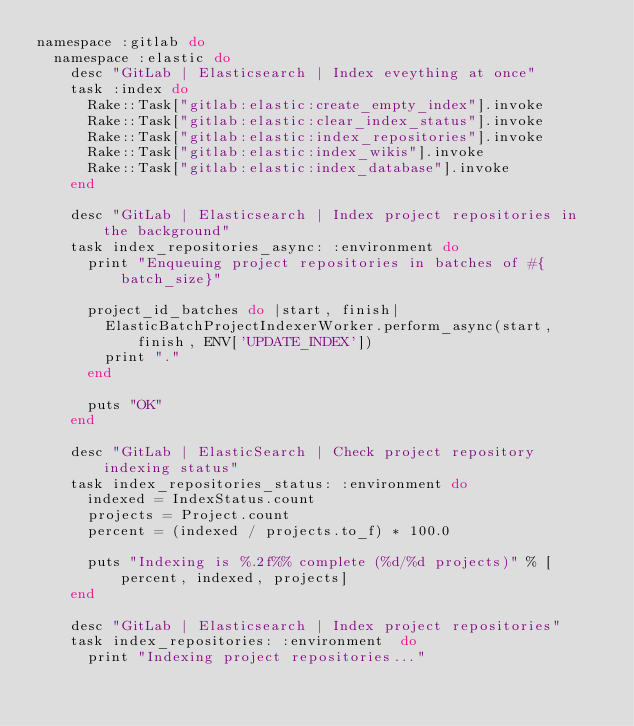Convert code to text. <code><loc_0><loc_0><loc_500><loc_500><_Ruby_>namespace :gitlab do
  namespace :elastic do
    desc "GitLab | Elasticsearch | Index eveything at once"
    task :index do
      Rake::Task["gitlab:elastic:create_empty_index"].invoke
      Rake::Task["gitlab:elastic:clear_index_status"].invoke
      Rake::Task["gitlab:elastic:index_repositories"].invoke
      Rake::Task["gitlab:elastic:index_wikis"].invoke
      Rake::Task["gitlab:elastic:index_database"].invoke
    end

    desc "GitLab | Elasticsearch | Index project repositories in the background"
    task index_repositories_async: :environment do
      print "Enqueuing project repositories in batches of #{batch_size}"

      project_id_batches do |start, finish|
        ElasticBatchProjectIndexerWorker.perform_async(start, finish, ENV['UPDATE_INDEX'])
        print "."
      end

      puts "OK"
    end

    desc "GitLab | ElasticSearch | Check project repository indexing status"
    task index_repositories_status: :environment do
      indexed = IndexStatus.count
      projects = Project.count
      percent = (indexed / projects.to_f) * 100.0

      puts "Indexing is %.2f%% complete (%d/%d projects)" % [percent, indexed, projects]
    end

    desc "GitLab | Elasticsearch | Index project repositories"
    task index_repositories: :environment  do
      print "Indexing project repositories..."
</code> 